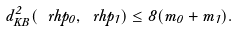Convert formula to latex. <formula><loc_0><loc_0><loc_500><loc_500>d _ { K B } ^ { 2 } ( \ r h p _ { 0 } , \ r h p _ { 1 } ) \leq 8 ( m _ { 0 } + m _ { 1 } ) .</formula> 